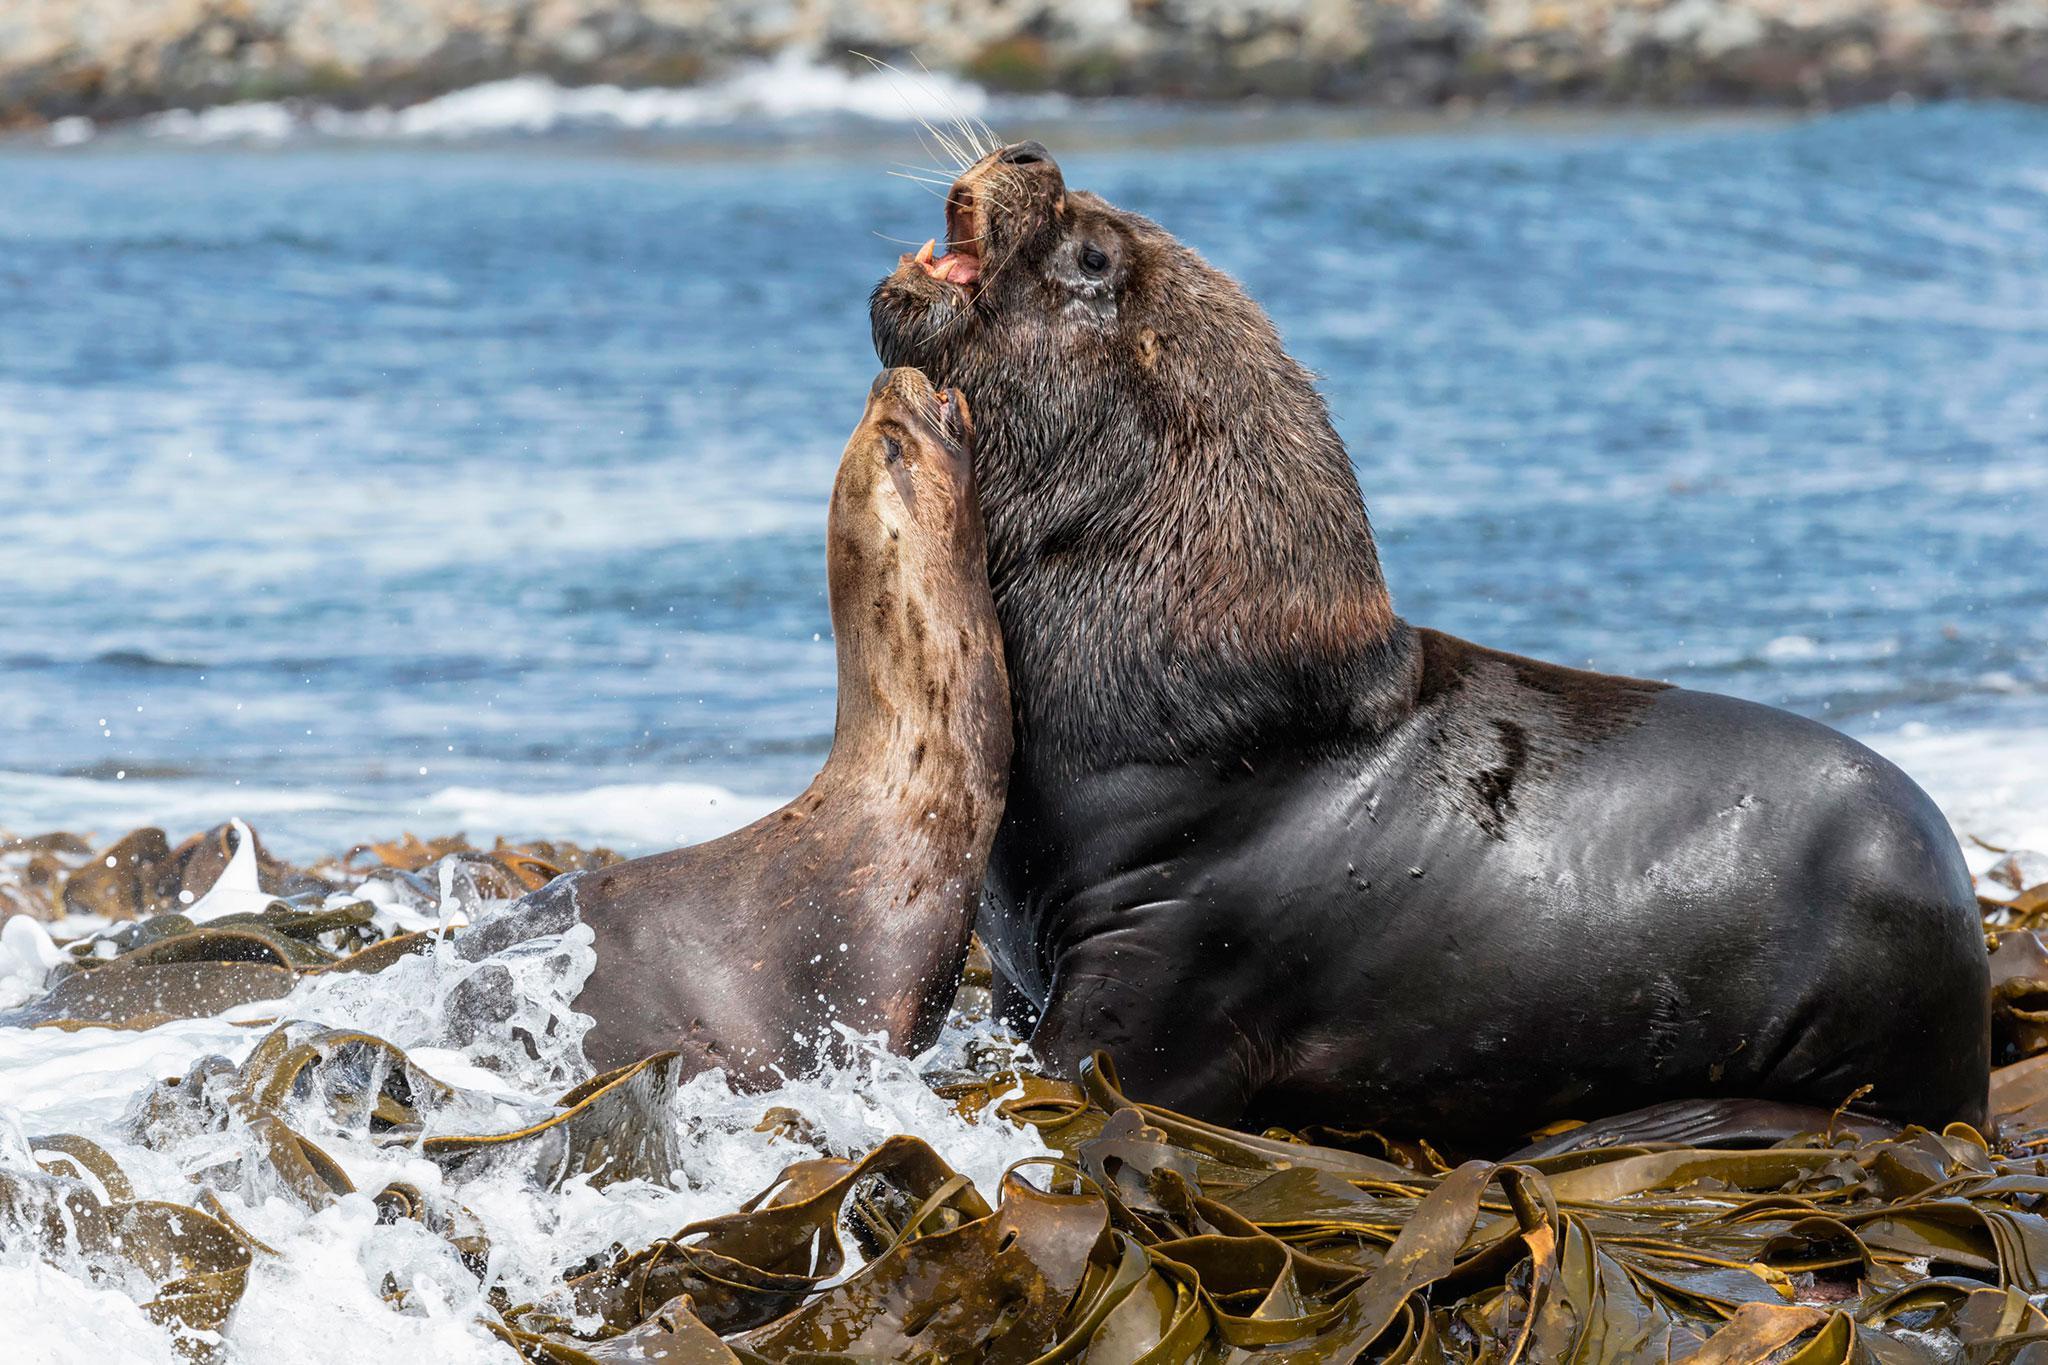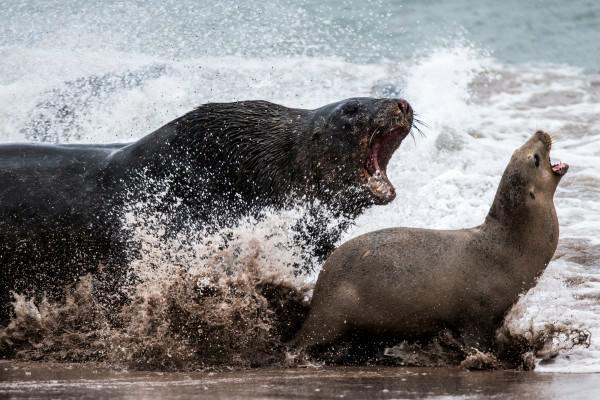The first image is the image on the left, the second image is the image on the right. Analyze the images presented: Is the assertion "An image shows exactly two seals in direct contact, posed face to face." valid? Answer yes or no. Yes. The first image is the image on the left, the second image is the image on the right. Considering the images on both sides, is "The left image only has two seals." valid? Answer yes or no. Yes. 